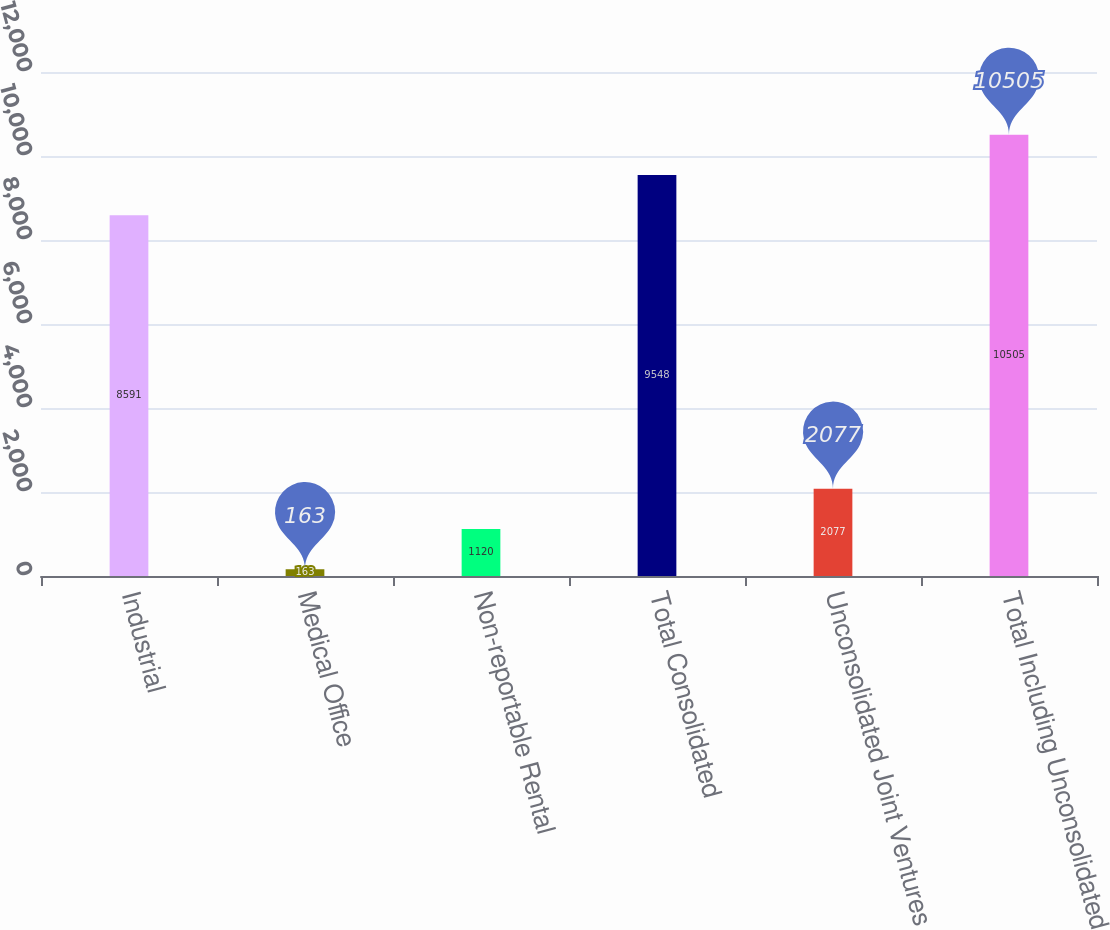Convert chart. <chart><loc_0><loc_0><loc_500><loc_500><bar_chart><fcel>Industrial<fcel>Medical Office<fcel>Non-reportable Rental<fcel>Total Consolidated<fcel>Unconsolidated Joint Ventures<fcel>Total Including Unconsolidated<nl><fcel>8591<fcel>163<fcel>1120<fcel>9548<fcel>2077<fcel>10505<nl></chart> 